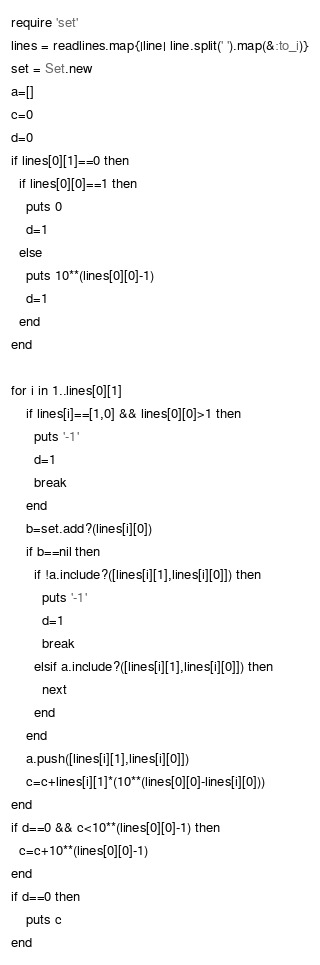Convert code to text. <code><loc_0><loc_0><loc_500><loc_500><_Ruby_>require 'set'
lines = readlines.map{|line| line.split(' ').map(&:to_i)}
set = Set.new
a=[]
c=0
d=0
if lines[0][1]==0 then
  if lines[0][0]==1 then
    puts 0
    d=1
  else
  	puts 10**(lines[0][0]-1)
    d=1
  end
end

for i in 1..lines[0][1]
	if lines[i]==[1,0] && lines[0][0]>1 then
      puts '-1'
      d=1
      break
    end
    b=set.add?(lines[i][0])
    if b==nil then
      if !a.include?([lines[i][1],lines[i][0]]) then
        puts '-1'
        d=1
        break
      elsif a.include?([lines[i][1],lines[i][0]]) then
        next
      end
    end
    a.push([lines[i][1],lines[i][0]])
    c=c+lines[i][1]*(10**(lines[0][0]-lines[i][0]))
end
if d==0 && c<10**(lines[0][0]-1) then
  c=c+10**(lines[0][0]-1)
end
if d==0 then
	puts c
end</code> 